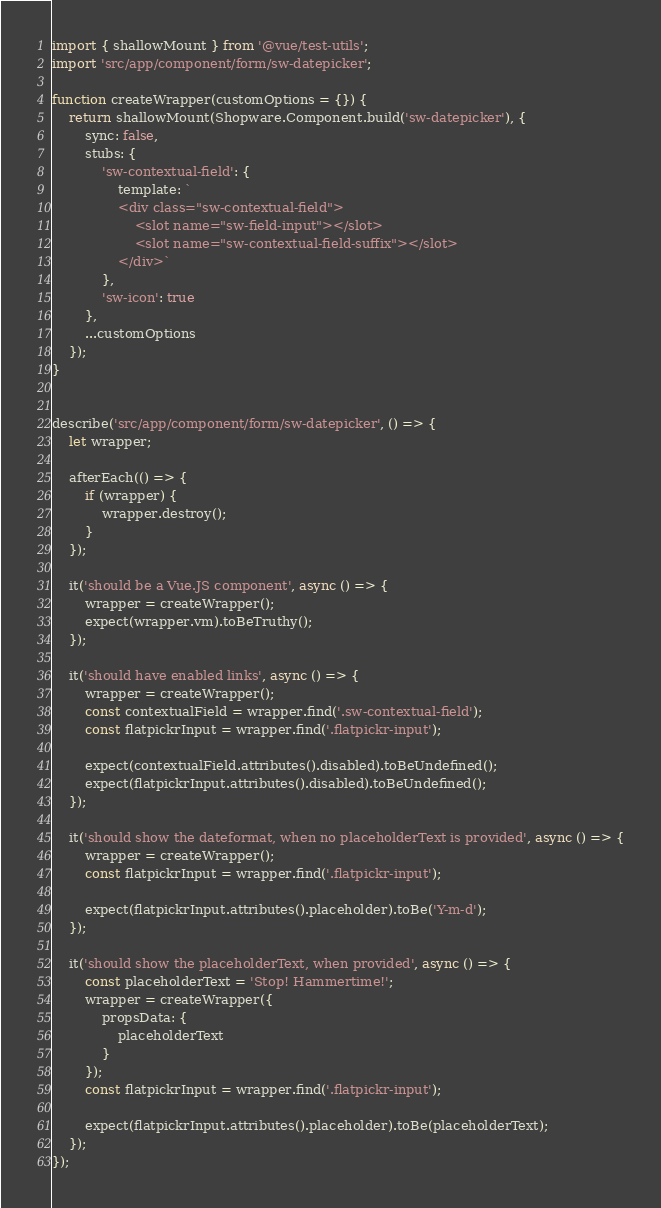Convert code to text. <code><loc_0><loc_0><loc_500><loc_500><_JavaScript_>import { shallowMount } from '@vue/test-utils';
import 'src/app/component/form/sw-datepicker';

function createWrapper(customOptions = {}) {
    return shallowMount(Shopware.Component.build('sw-datepicker'), {
        sync: false,
        stubs: {
            'sw-contextual-field': {
                template: `
                <div class="sw-contextual-field">
                    <slot name="sw-field-input"></slot>
                    <slot name="sw-contextual-field-suffix"></slot>
                </div>`
            },
            'sw-icon': true
        },
        ...customOptions
    });
}


describe('src/app/component/form/sw-datepicker', () => {
    let wrapper;

    afterEach(() => {
        if (wrapper) {
            wrapper.destroy();
        }
    });

    it('should be a Vue.JS component', async () => {
        wrapper = createWrapper();
        expect(wrapper.vm).toBeTruthy();
    });

    it('should have enabled links', async () => {
        wrapper = createWrapper();
        const contextualField = wrapper.find('.sw-contextual-field');
        const flatpickrInput = wrapper.find('.flatpickr-input');

        expect(contextualField.attributes().disabled).toBeUndefined();
        expect(flatpickrInput.attributes().disabled).toBeUndefined();
    });

    it('should show the dateformat, when no placeholderText is provided', async () => {
        wrapper = createWrapper();
        const flatpickrInput = wrapper.find('.flatpickr-input');

        expect(flatpickrInput.attributes().placeholder).toBe('Y-m-d');
    });

    it('should show the placeholderText, when provided', async () => {
        const placeholderText = 'Stop! Hammertime!';
        wrapper = createWrapper({
            propsData: {
                placeholderText
            }
        });
        const flatpickrInput = wrapper.find('.flatpickr-input');

        expect(flatpickrInput.attributes().placeholder).toBe(placeholderText);
    });
});
</code> 